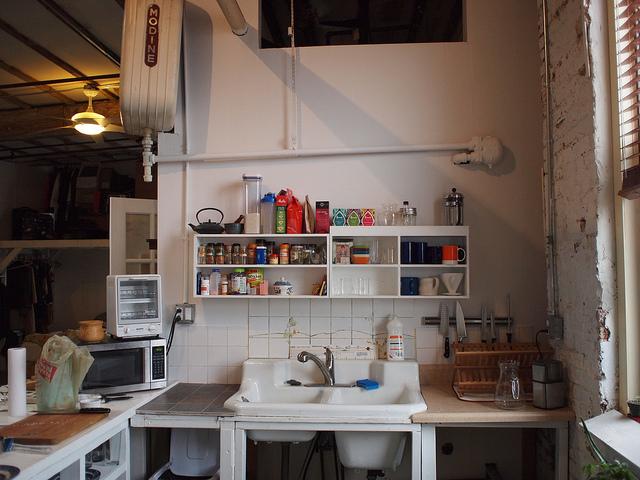Can you see a microwave?
Quick response, please. Yes. Is this a basement?
Keep it brief. No. What is white and sitting on top of the microwave?
Concise answer only. Toaster oven. 